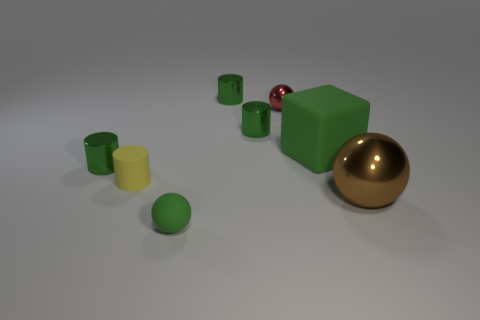Subtract all blue blocks. How many green cylinders are left? 3 Add 1 small rubber cylinders. How many objects exist? 9 Subtract all blocks. How many objects are left? 7 Add 3 tiny metal objects. How many tiny metal objects exist? 7 Subtract 0 gray cubes. How many objects are left? 8 Subtract all tiny red rubber spheres. Subtract all yellow cylinders. How many objects are left? 7 Add 3 tiny red things. How many tiny red things are left? 4 